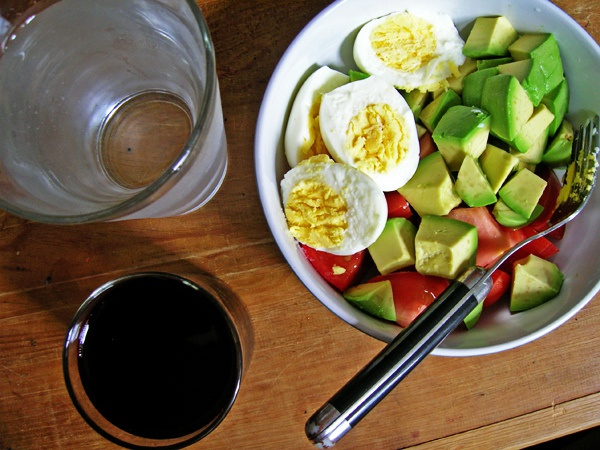Describe the objects in this image and their specific colors. I can see dining table in black, gray, maroon, brown, and white tones, bowl in black, white, darkgreen, gray, and khaki tones, cup in black, gray, and maroon tones, cup in black, maroon, and brown tones, and fork in black, gray, olive, and maroon tones in this image. 